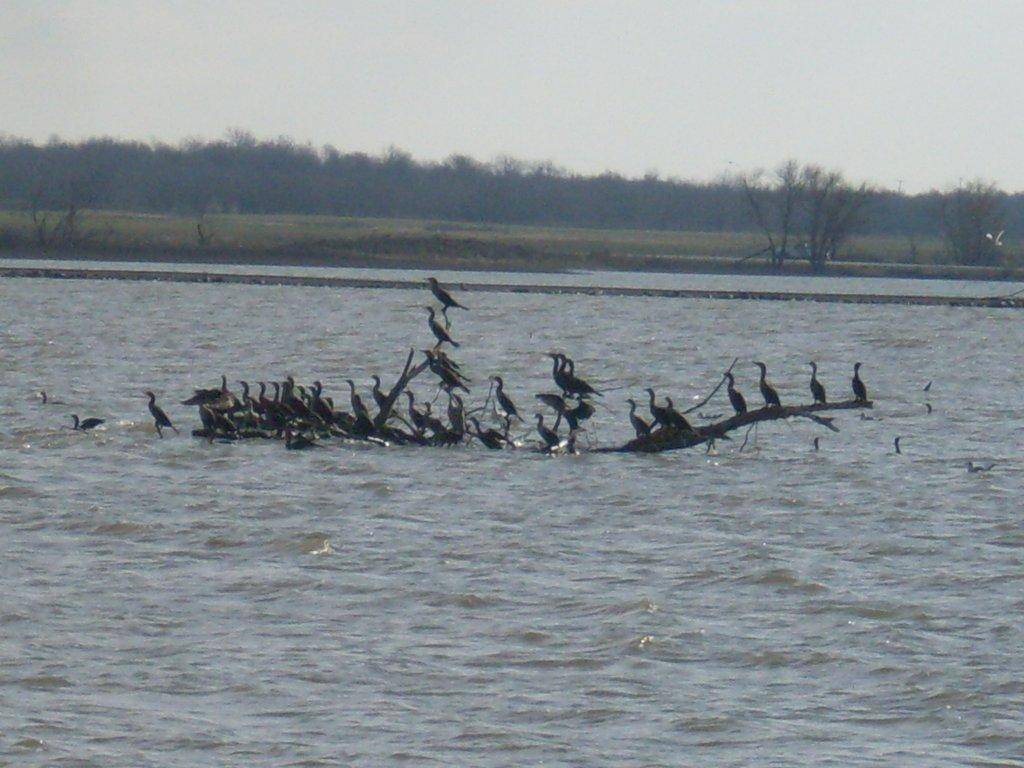What type of animals can be seen in the image? There are birds in the image. What are the birds standing on? The birds are standing on a plant. Where is the plant located? The plant is in the middle of a lake. What can be seen in the background of the image? There are trees and the sky visible in the background of the image. Are the trees on land or in the water? The trees are on land. What type of cap is the horse wearing in the image? There is no horse or cap present in the image; it features birds standing on a plant in the middle of a lake. 